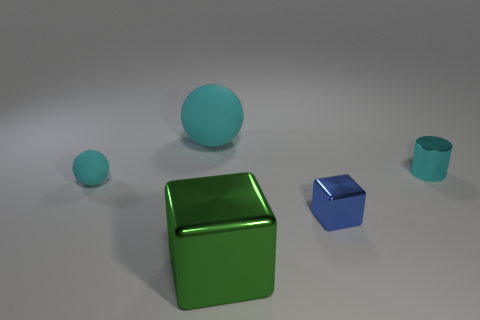There is a cube left of the tiny blue thing; what material is it?
Offer a terse response. Metal. What number of blue objects have the same shape as the small cyan shiny object?
Your answer should be very brief. 0. Are there the same number of gray matte spheres and large matte things?
Your answer should be compact. No. What material is the cyan sphere in front of the thing behind the tiny cyan metallic thing?
Keep it short and to the point. Rubber. The small metal thing that is the same color as the large rubber ball is what shape?
Make the answer very short. Cylinder. Is there another cylinder that has the same material as the cyan cylinder?
Your answer should be very brief. No. What is the shape of the small blue metallic object?
Provide a succinct answer. Cube. How many cyan rubber things are there?
Ensure brevity in your answer.  2. The thing that is left of the big sphere that is to the left of the large shiny cube is what color?
Your answer should be compact. Cyan. What color is the shiny object that is the same size as the blue block?
Ensure brevity in your answer.  Cyan. 